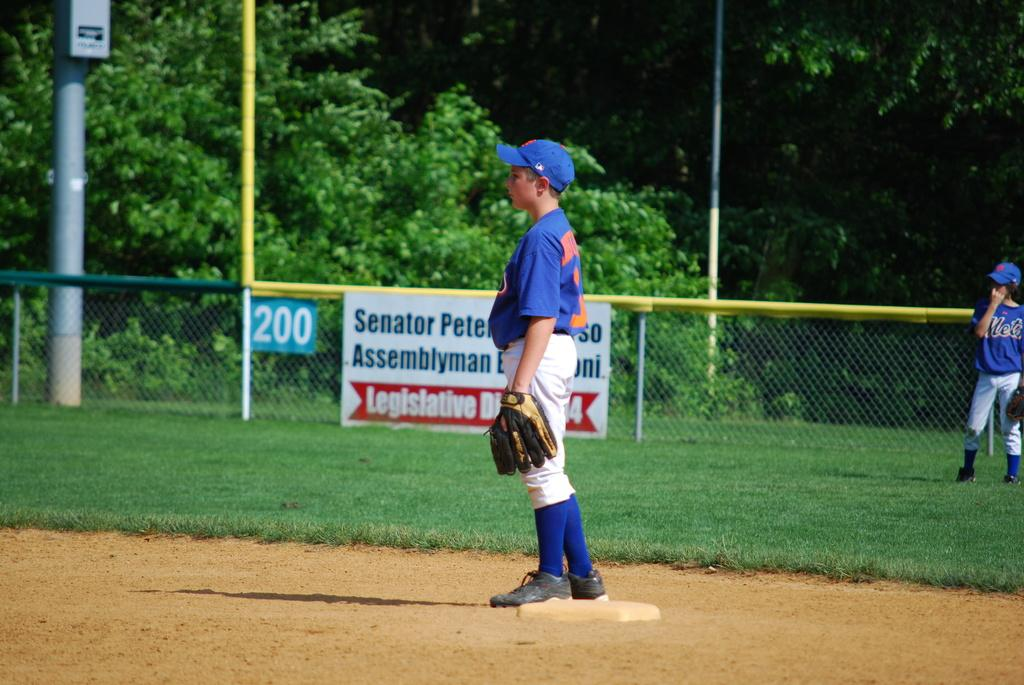<image>
Relay a brief, clear account of the picture shown. A young boy plays baseball on a field with a sign hung on the fence for Senator Pete Assemblyman. 